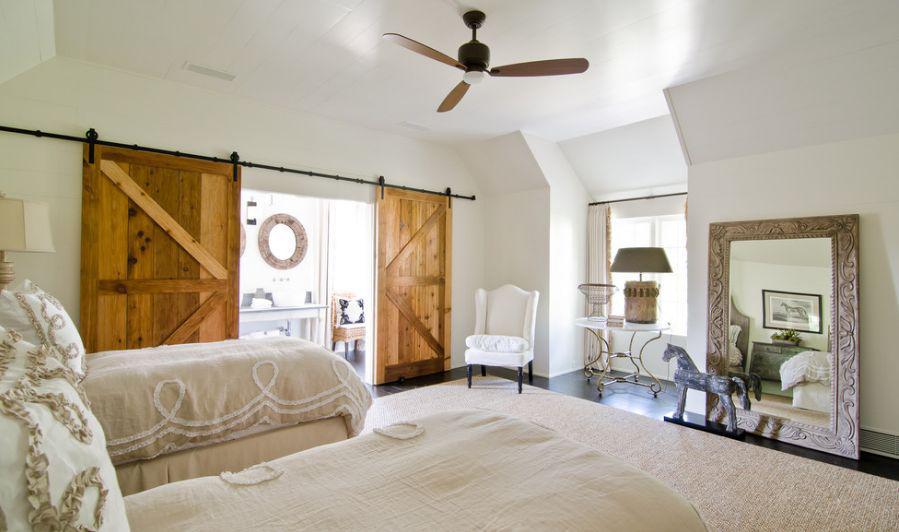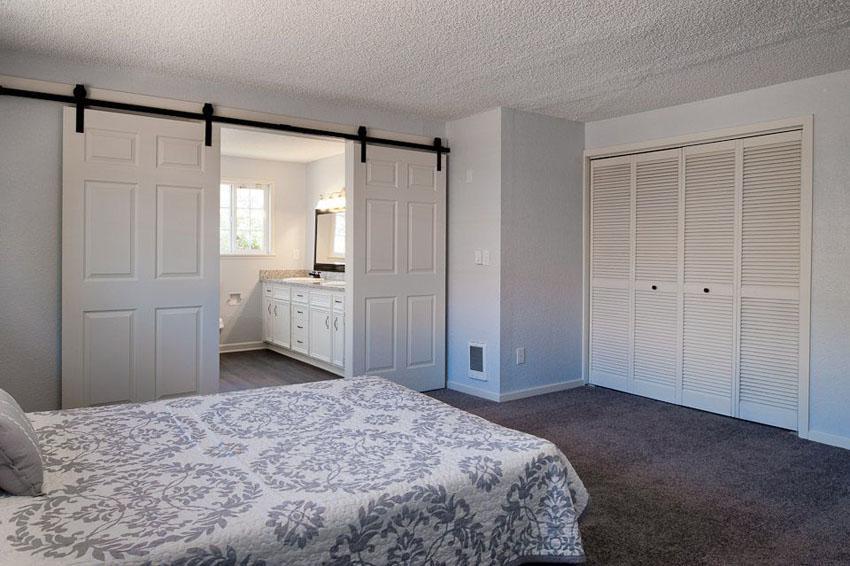The first image is the image on the left, the second image is the image on the right. For the images displayed, is the sentence "There is a white chair shown in one of the images." factually correct? Answer yes or no. Yes. The first image is the image on the left, the second image is the image on the right. Considering the images on both sides, is "There is a bed in the image on the right." valid? Answer yes or no. Yes. 